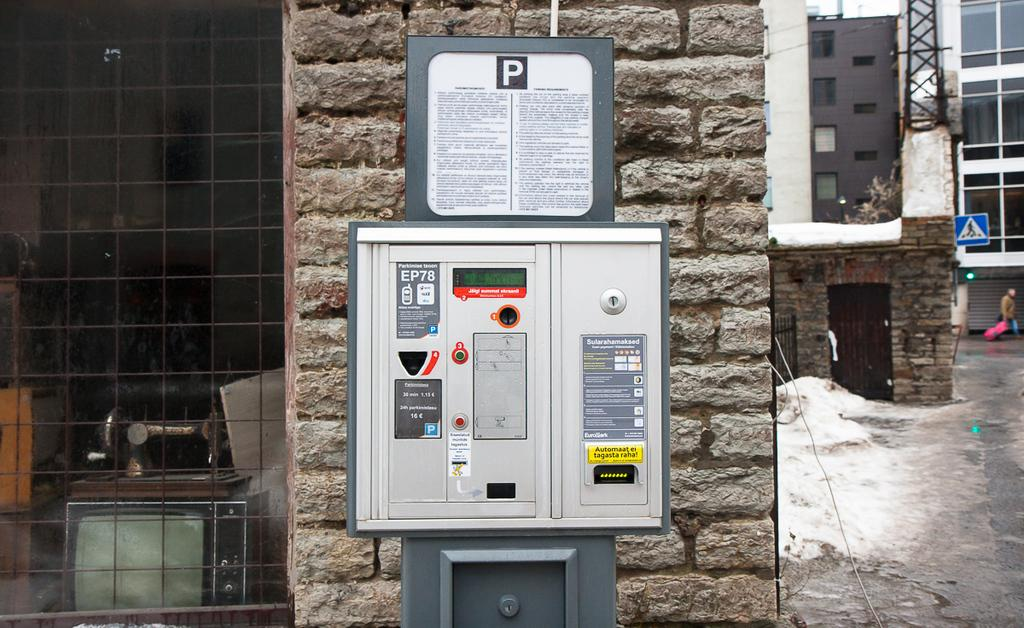<image>
Render a clear and concise summary of the photo. a sign above an electric box with the letter P 